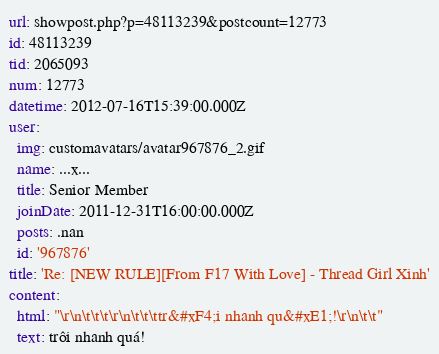Convert code to text. <code><loc_0><loc_0><loc_500><loc_500><_YAML_>url: showpost.php?p=48113239&postcount=12773
id: 48113239
tid: 2065093
num: 12773
datetime: 2012-07-16T15:39:00.000Z
user:
  img: customavatars/avatar967876_2.gif
  name: ...x...
  title: Senior Member
  joinDate: 2011-12-31T16:00:00.000Z
  posts: .nan
  id: '967876'
title: 'Re: [NEW RULE][From F17 With Love] - Thread Girl Xinh'
content:
  html: "\r\n\t\t\t\r\n\t\t\ttr&#xF4;i nhanh qu&#xE1;!\r\n\t\t"
  text: trôi nhanh quá!
</code> 